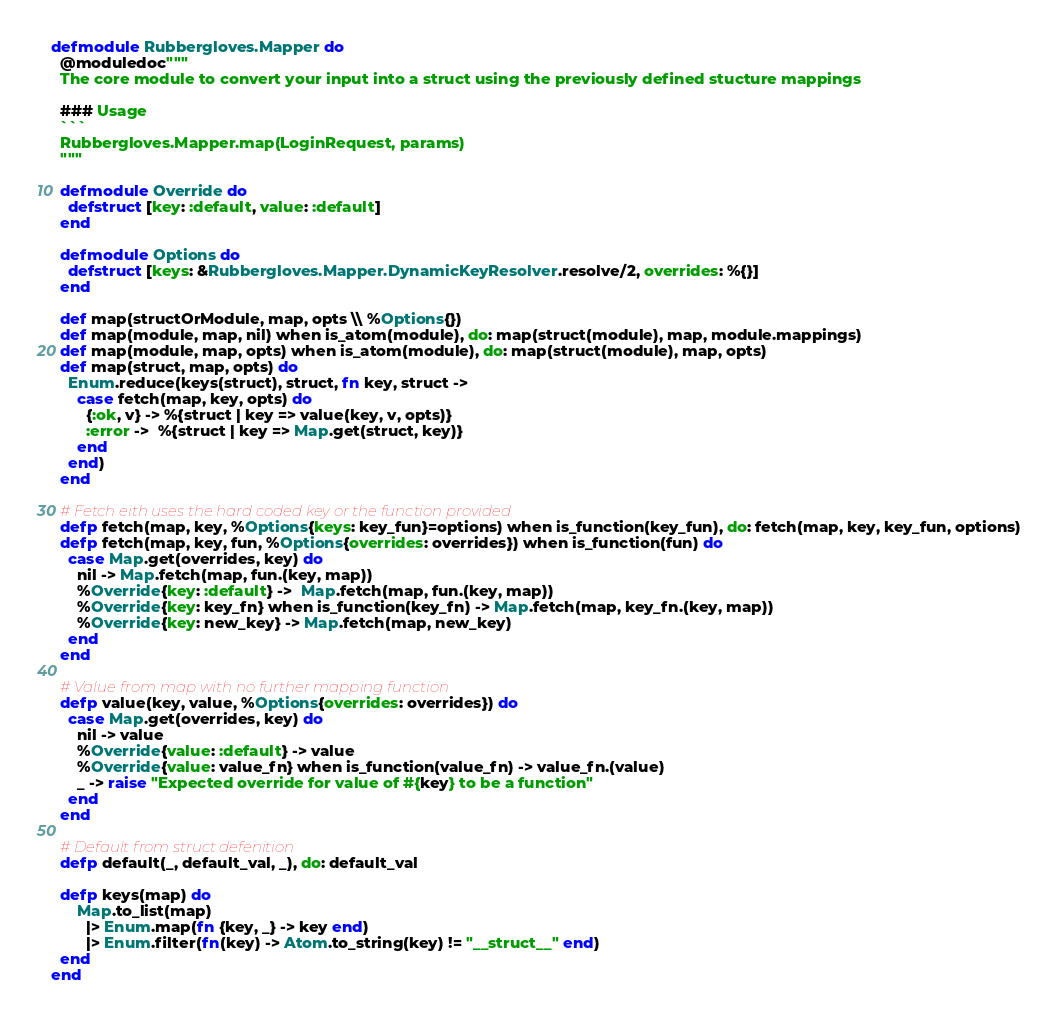Convert code to text. <code><loc_0><loc_0><loc_500><loc_500><_Elixir_>defmodule Rubbergloves.Mapper do
  @moduledoc"""
  The core module to convert your input into a struct using the previously defined stucture mappings

  ### Usage
  ```
  Rubbergloves.Mapper.map(LoginRequest, params)
  """

  defmodule Override do
    defstruct [key: :default, value: :default]
  end

  defmodule Options do
    defstruct [keys: &Rubbergloves.Mapper.DynamicKeyResolver.resolve/2, overrides: %{}]
  end

  def map(structOrModule, map, opts \\ %Options{})
  def map(module, map, nil) when is_atom(module), do: map(struct(module), map, module.mappings)
  def map(module, map, opts) when is_atom(module), do: map(struct(module), map, opts)
  def map(struct, map, opts) do
    Enum.reduce(keys(struct), struct, fn key, struct ->
      case fetch(map, key, opts) do
        {:ok, v} -> %{struct | key => value(key, v, opts)}
        :error ->  %{struct | key => Map.get(struct, key)}
      end
    end)
  end

  # Fetch eith uses the hard coded key or the function provided
  defp fetch(map, key, %Options{keys: key_fun}=options) when is_function(key_fun), do: fetch(map, key, key_fun, options)
  defp fetch(map, key, fun, %Options{overrides: overrides}) when is_function(fun) do
    case Map.get(overrides, key) do
      nil -> Map.fetch(map, fun.(key, map))
      %Override{key: :default} ->  Map.fetch(map, fun.(key, map))
      %Override{key: key_fn} when is_function(key_fn) -> Map.fetch(map, key_fn.(key, map))
      %Override{key: new_key} -> Map.fetch(map, new_key)
    end
  end

  # Value from map with no further mapping function
  defp value(key, value, %Options{overrides: overrides}) do
    case Map.get(overrides, key) do
      nil -> value
      %Override{value: :default} -> value
      %Override{value: value_fn} when is_function(value_fn) -> value_fn.(value)
      _ -> raise "Expected override for value of #{key} to be a function"
    end
  end

  # Default from struct defenition
  defp default(_, default_val, _), do: default_val

  defp keys(map) do
      Map.to_list(map)
        |> Enum.map(fn {key, _} -> key end)
        |> Enum.filter(fn(key) -> Atom.to_string(key) != "__struct__" end)
  end
end
</code> 